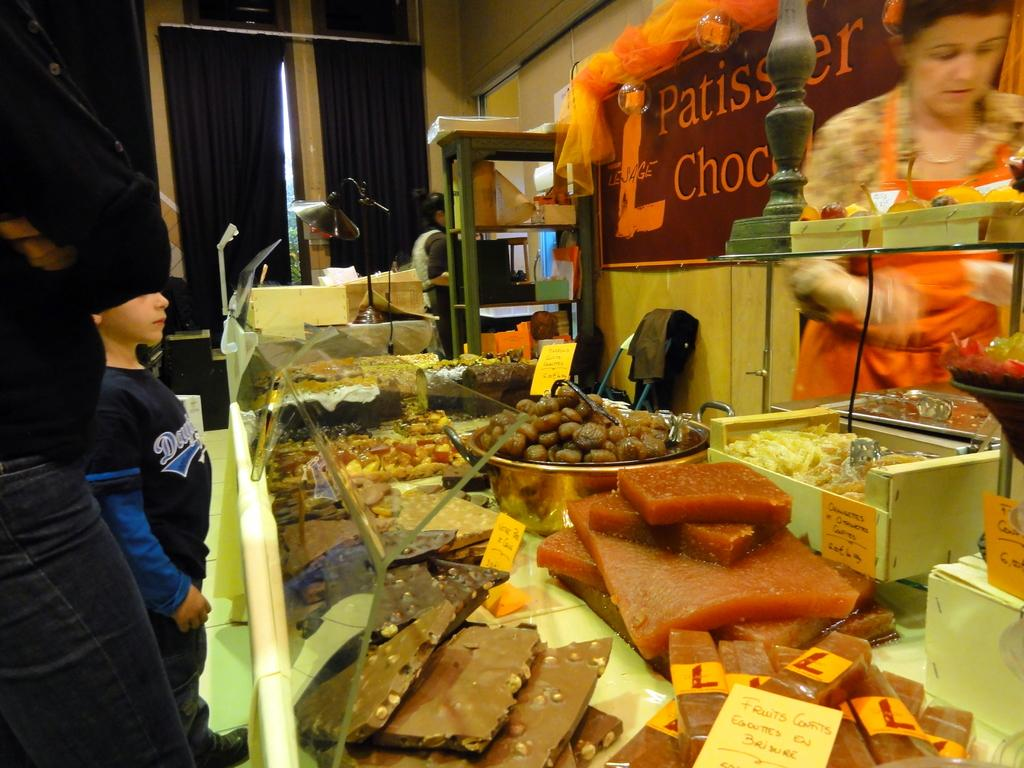<image>
Share a concise interpretation of the image provided. The counter of Patissier Chocolate with many goods on display for a young boy to peruse. 